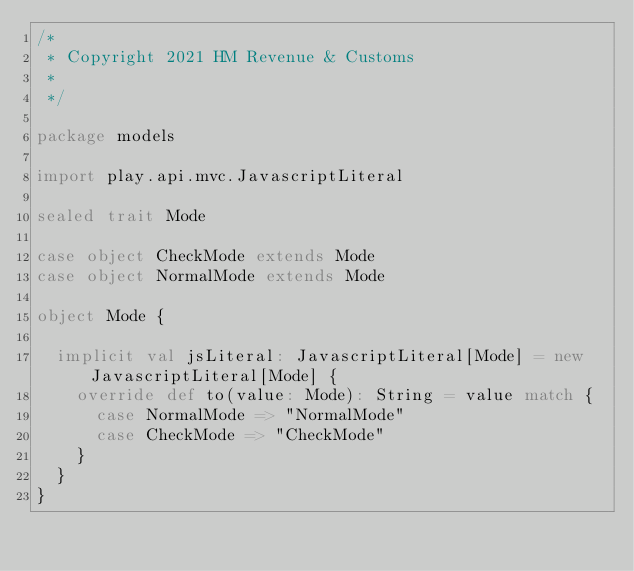<code> <loc_0><loc_0><loc_500><loc_500><_Scala_>/*
 * Copyright 2021 HM Revenue & Customs
 *
 */

package models

import play.api.mvc.JavascriptLiteral

sealed trait Mode

case object CheckMode extends Mode
case object NormalMode extends Mode

object Mode {

  implicit val jsLiteral: JavascriptLiteral[Mode] = new JavascriptLiteral[Mode] {
    override def to(value: Mode): String = value match {
      case NormalMode => "NormalMode"
      case CheckMode => "CheckMode"
    }
  }
}
</code> 